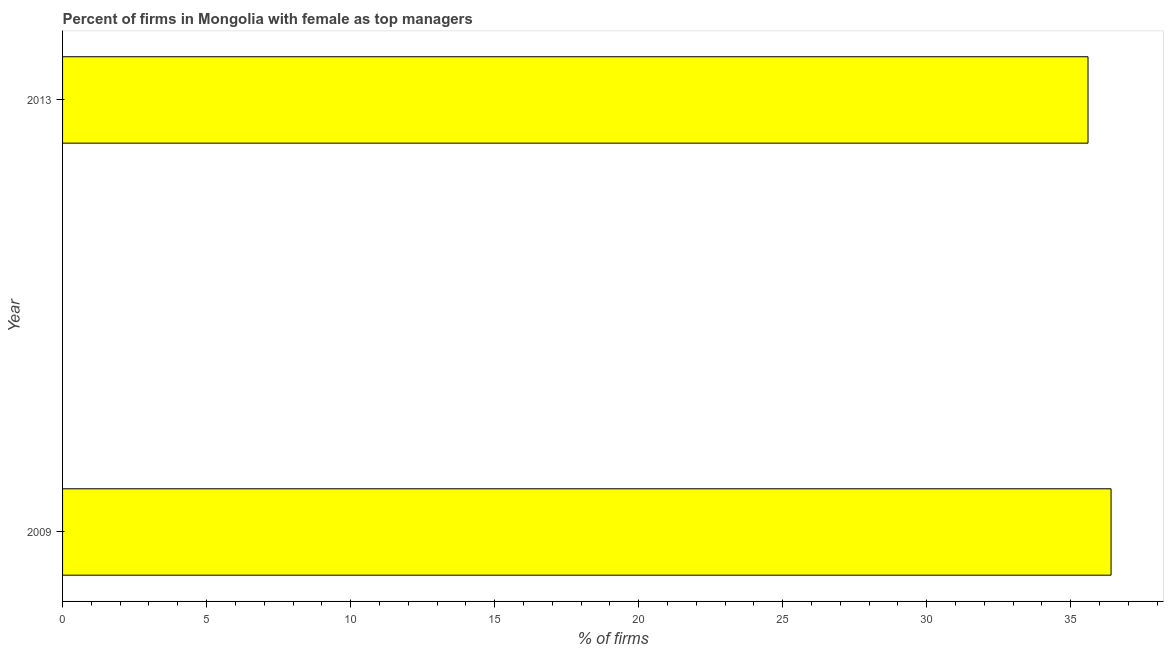What is the title of the graph?
Keep it short and to the point. Percent of firms in Mongolia with female as top managers. What is the label or title of the X-axis?
Make the answer very short. % of firms. What is the label or title of the Y-axis?
Your answer should be very brief. Year. What is the percentage of firms with female as top manager in 2009?
Your answer should be very brief. 36.4. Across all years, what is the maximum percentage of firms with female as top manager?
Offer a very short reply. 36.4. Across all years, what is the minimum percentage of firms with female as top manager?
Offer a terse response. 35.6. In which year was the percentage of firms with female as top manager maximum?
Make the answer very short. 2009. In which year was the percentage of firms with female as top manager minimum?
Ensure brevity in your answer.  2013. What is the difference between the percentage of firms with female as top manager in 2009 and 2013?
Offer a very short reply. 0.8. What is the median percentage of firms with female as top manager?
Ensure brevity in your answer.  36. In how many years, is the percentage of firms with female as top manager greater than 17 %?
Keep it short and to the point. 2. Do a majority of the years between 2009 and 2013 (inclusive) have percentage of firms with female as top manager greater than 31 %?
Provide a succinct answer. Yes. What is the ratio of the percentage of firms with female as top manager in 2009 to that in 2013?
Provide a succinct answer. 1.02. How many years are there in the graph?
Keep it short and to the point. 2. What is the difference between two consecutive major ticks on the X-axis?
Your answer should be very brief. 5. Are the values on the major ticks of X-axis written in scientific E-notation?
Provide a succinct answer. No. What is the % of firms of 2009?
Offer a very short reply. 36.4. What is the % of firms in 2013?
Provide a succinct answer. 35.6. What is the ratio of the % of firms in 2009 to that in 2013?
Make the answer very short. 1.02. 